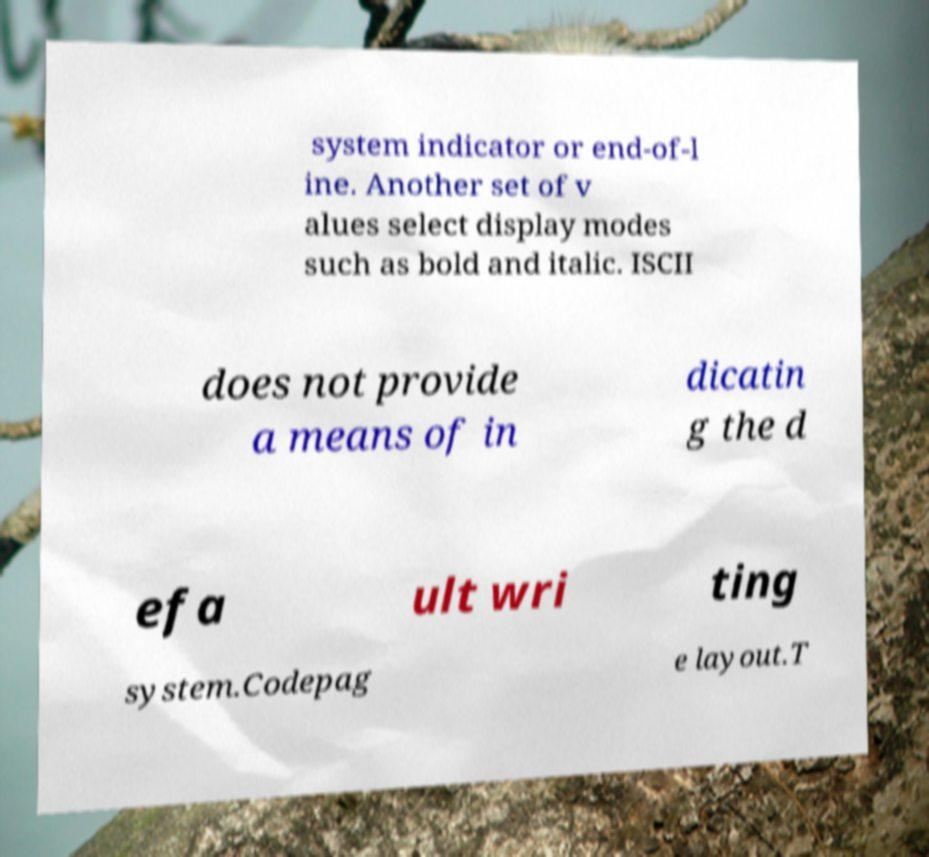Please identify and transcribe the text found in this image. system indicator or end-of-l ine. Another set of v alues select display modes such as bold and italic. ISCII does not provide a means of in dicatin g the d efa ult wri ting system.Codepag e layout.T 